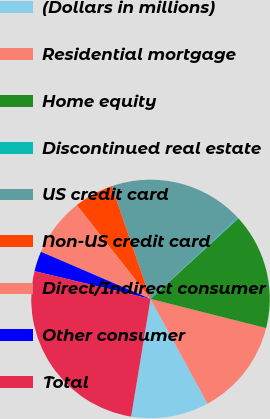Convert chart to OTSL. <chart><loc_0><loc_0><loc_500><loc_500><pie_chart><fcel>(Dollars in millions)<fcel>Residential mortgage<fcel>Home equity<fcel>Discontinued real estate<fcel>US credit card<fcel>Non-US credit card<fcel>Direct/Indirect consumer<fcel>Other consumer<fcel>Total<nl><fcel>10.53%<fcel>13.13%<fcel>15.73%<fcel>0.13%<fcel>18.34%<fcel>5.33%<fcel>7.93%<fcel>2.73%<fcel>26.14%<nl></chart> 